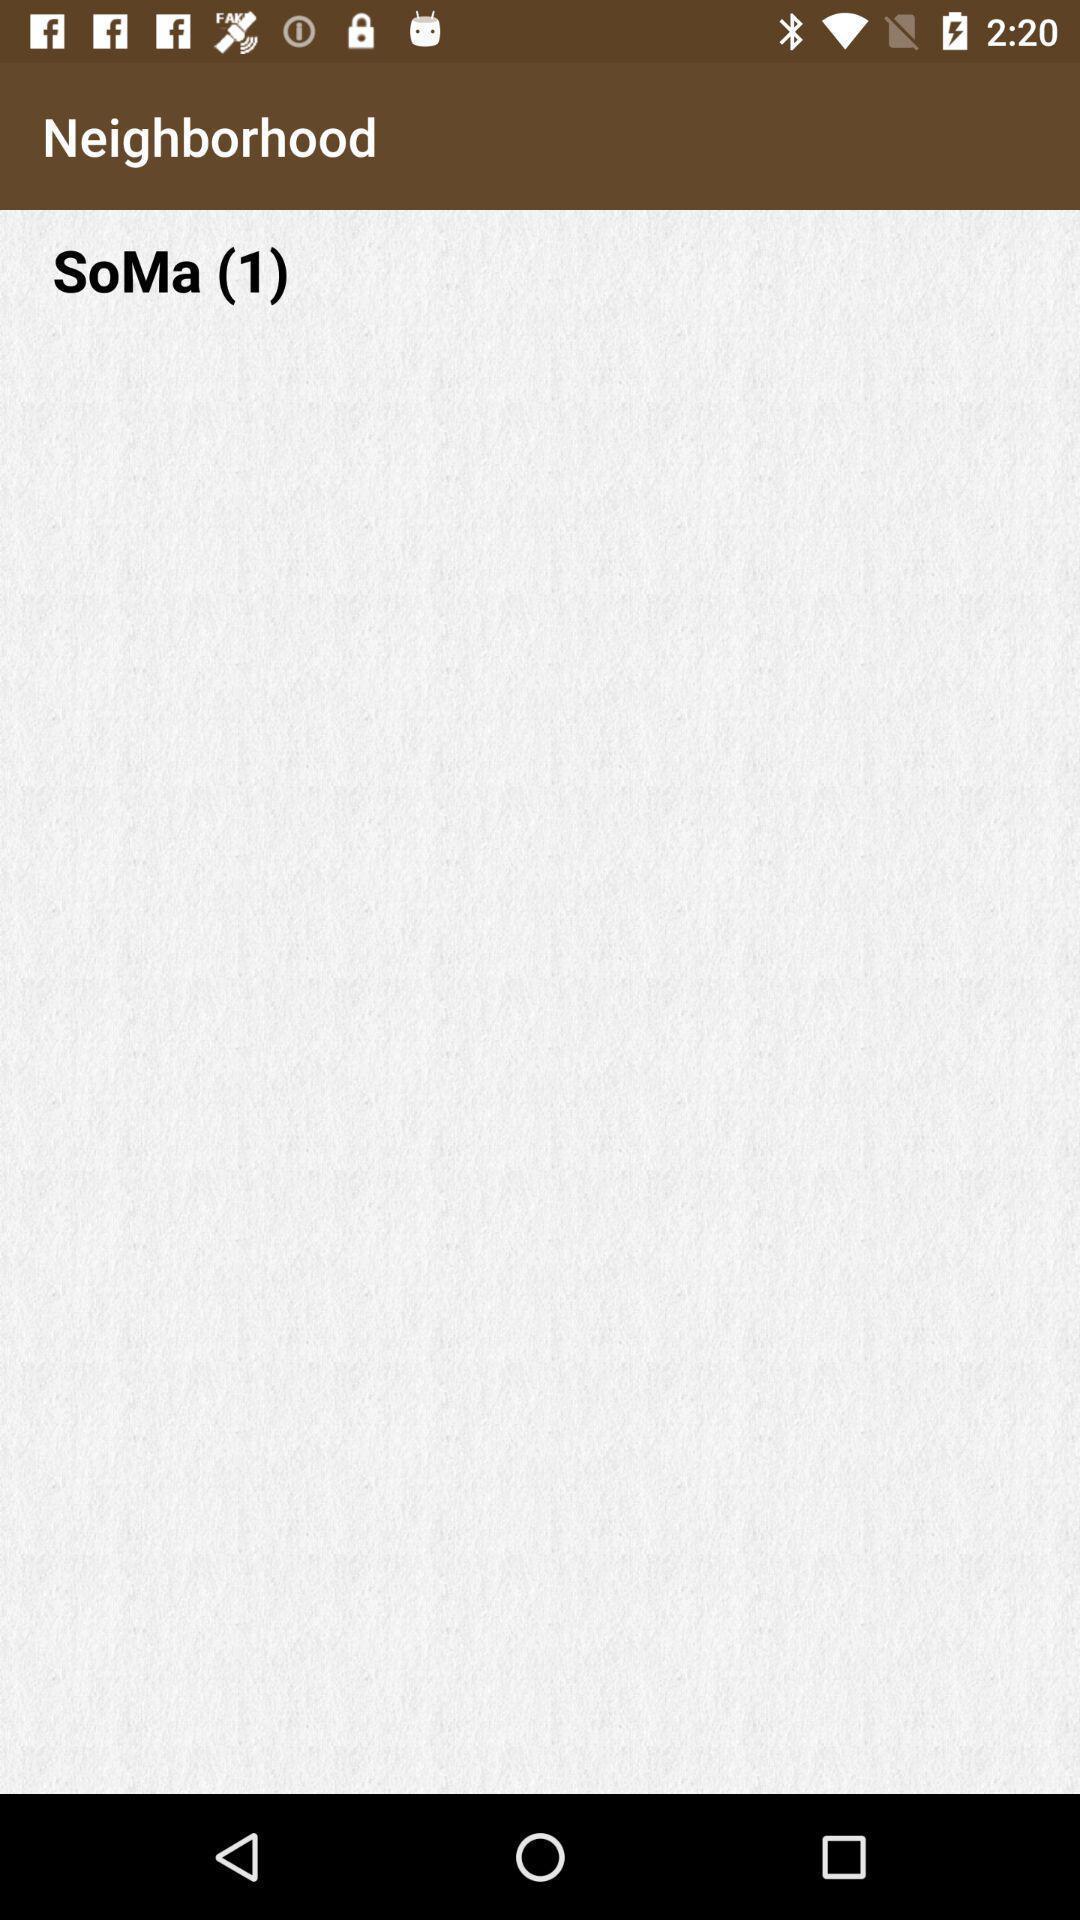Describe the key features of this screenshot. Screen displaying the neighborhood page. 